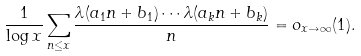Convert formula to latex. <formula><loc_0><loc_0><loc_500><loc_500>\frac { 1 } { \log x } \sum _ { n \leq x } \frac { \lambda ( a _ { 1 } n + b _ { 1 } ) \cdots \lambda ( a _ { k } n + b _ { k } ) } { n } = o _ { x \to \infty } ( 1 ) .</formula> 